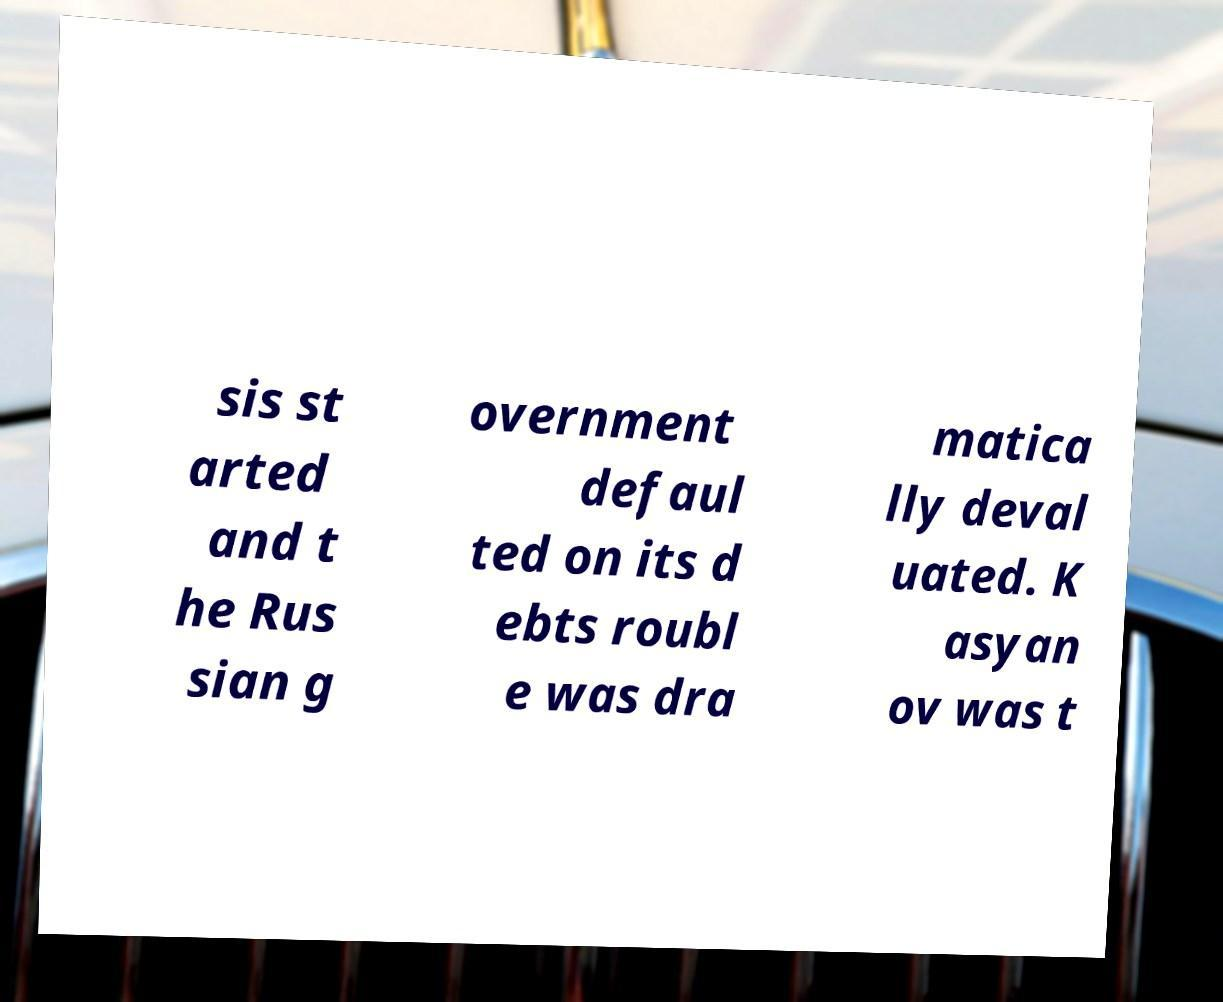For documentation purposes, I need the text within this image transcribed. Could you provide that? sis st arted and t he Rus sian g overnment defaul ted on its d ebts roubl e was dra matica lly deval uated. K asyan ov was t 